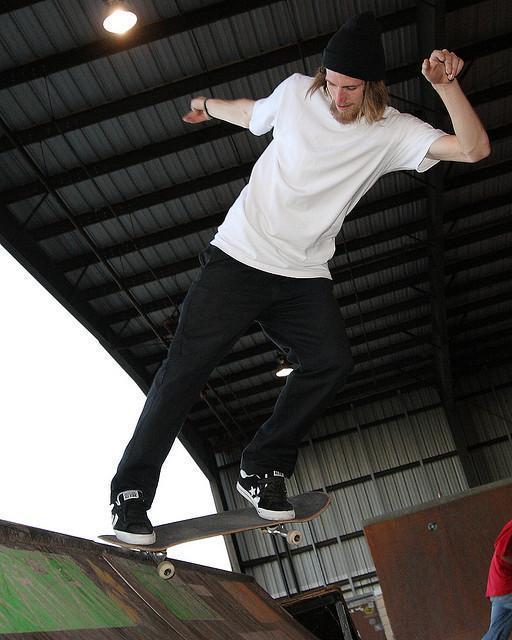How many wheels are in this image?
Give a very brief answer. 2. How many people are visible?
Give a very brief answer. 2. How many giraffes are shorter that the lamp post?
Give a very brief answer. 0. 